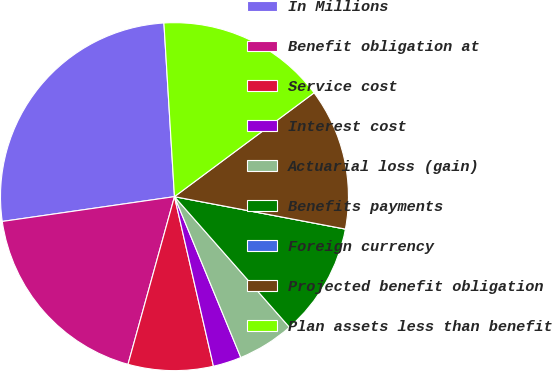<chart> <loc_0><loc_0><loc_500><loc_500><pie_chart><fcel>In Millions<fcel>Benefit obligation at<fcel>Service cost<fcel>Interest cost<fcel>Actuarial loss (gain)<fcel>Benefits payments<fcel>Foreign currency<fcel>Projected benefit obligation<fcel>Plan assets less than benefit<nl><fcel>26.31%<fcel>18.42%<fcel>7.9%<fcel>2.63%<fcel>5.26%<fcel>10.53%<fcel>0.0%<fcel>13.16%<fcel>15.79%<nl></chart> 